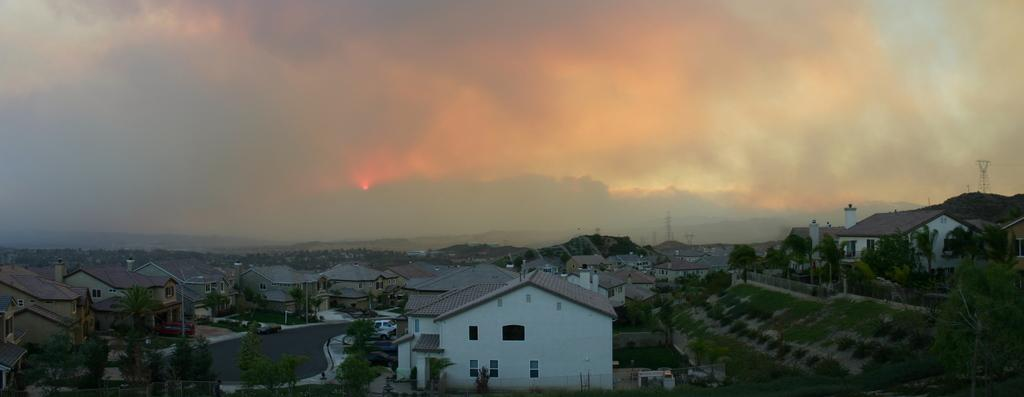What type of view is shown in the image? The image is an aerial view of a town. What can be seen in the town? There are many homes, buildings, and roads in the town. How are the homes situated in the town? Trees are present in front of homes. What is visible in the sky in the image? The sky is visible in the image, and clouds are present. What type of advertisement can be seen on the roof of the building in the image? There is no advertisement visible on the roof of any building in the image. Can you tell me how many wrens are perched on the trees in the image? There are no wrens present in the image; only trees are visible. 